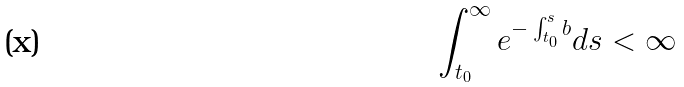Convert formula to latex. <formula><loc_0><loc_0><loc_500><loc_500>\int _ { t _ { 0 } } ^ { \infty } e ^ { - \int _ { t _ { 0 } } ^ { s } b } d s < \infty</formula> 